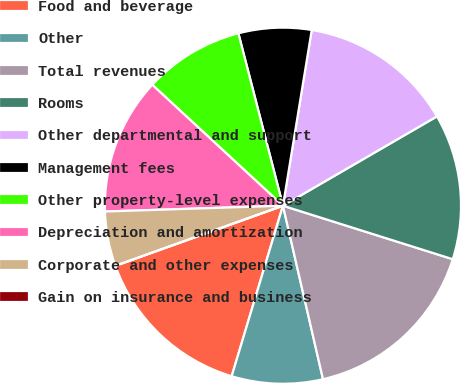Convert chart to OTSL. <chart><loc_0><loc_0><loc_500><loc_500><pie_chart><fcel>Food and beverage<fcel>Other<fcel>Total revenues<fcel>Rooms<fcel>Other departmental and support<fcel>Management fees<fcel>Other property-level expenses<fcel>Depreciation and amortization<fcel>Corporate and other expenses<fcel>Gain on insurance and business<nl><fcel>14.87%<fcel>8.26%<fcel>16.53%<fcel>13.22%<fcel>14.05%<fcel>6.61%<fcel>9.09%<fcel>12.4%<fcel>4.96%<fcel>0.0%<nl></chart> 